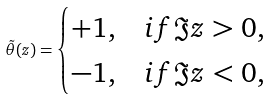<formula> <loc_0><loc_0><loc_500><loc_500>\tilde { \theta } ( z ) = \begin{cases} + 1 , & i f \Im z > 0 , \\ - 1 , & i f \Im z < 0 , \end{cases}</formula> 